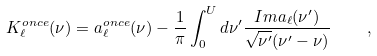<formula> <loc_0><loc_0><loc_500><loc_500>K _ { \ell } ^ { o n c e } ( \nu ) = a _ { \ell } ^ { o n c e } ( \nu ) - \frac { 1 } { \pi } \int _ { 0 } ^ { U } d \nu ^ { \prime } \frac { I m a _ { \ell } ( \nu ^ { \prime } ) } { \sqrt { \nu ^ { \prime } } ( \nu ^ { \prime } - \nu ) } \quad ,</formula> 